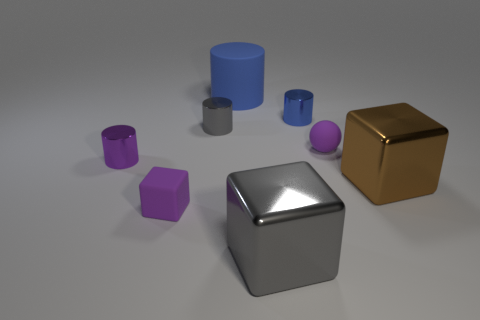Are the big cylinder and the big object in front of the large brown cube made of the same material?
Make the answer very short. No. What material is the large object that is in front of the gray shiny cylinder and to the left of the tiny ball?
Your answer should be very brief. Metal. The large thing behind the tiny purple ball that is left of the large brown thing is what color?
Keep it short and to the point. Blue. There is a tiny cylinder on the left side of the small purple cube; what material is it?
Your answer should be compact. Metal. Are there fewer large brown cylinders than blue matte objects?
Your answer should be very brief. Yes. Does the tiny gray metal object have the same shape as the purple object to the right of the gray block?
Your response must be concise. No. What is the shape of the matte thing that is behind the tiny purple cube and left of the tiny purple matte sphere?
Your answer should be very brief. Cylinder. Are there an equal number of gray metal things that are on the right side of the tiny matte block and gray metallic blocks that are behind the purple rubber ball?
Your answer should be compact. No. Is the shape of the small purple thing that is left of the small purple block the same as  the small blue object?
Give a very brief answer. Yes. How many brown things are either metallic things or cylinders?
Offer a terse response. 1. 